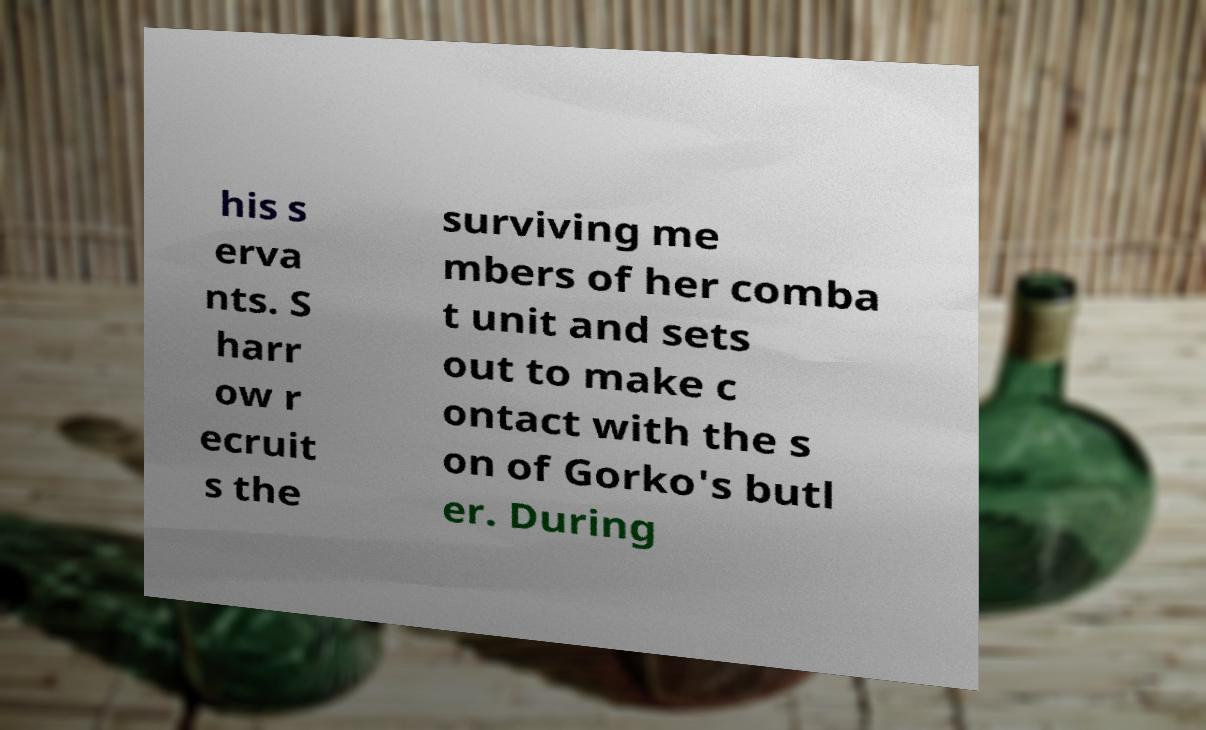I need the written content from this picture converted into text. Can you do that? his s erva nts. S harr ow r ecruit s the surviving me mbers of her comba t unit and sets out to make c ontact with the s on of Gorko's butl er. During 